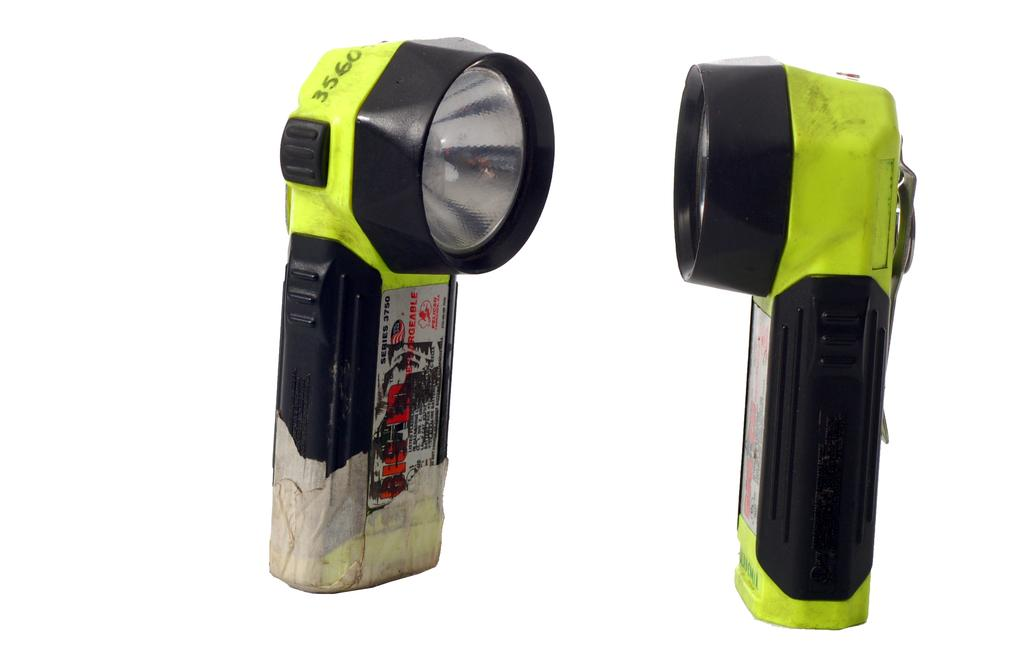What objects are present in the image that provide light? There are two torch lights in the image. What is written or printed on the torch lights? There is text on the torch lights. How many houses are visible in the image? There are no houses visible in the image; it only features two torch lights with text. 